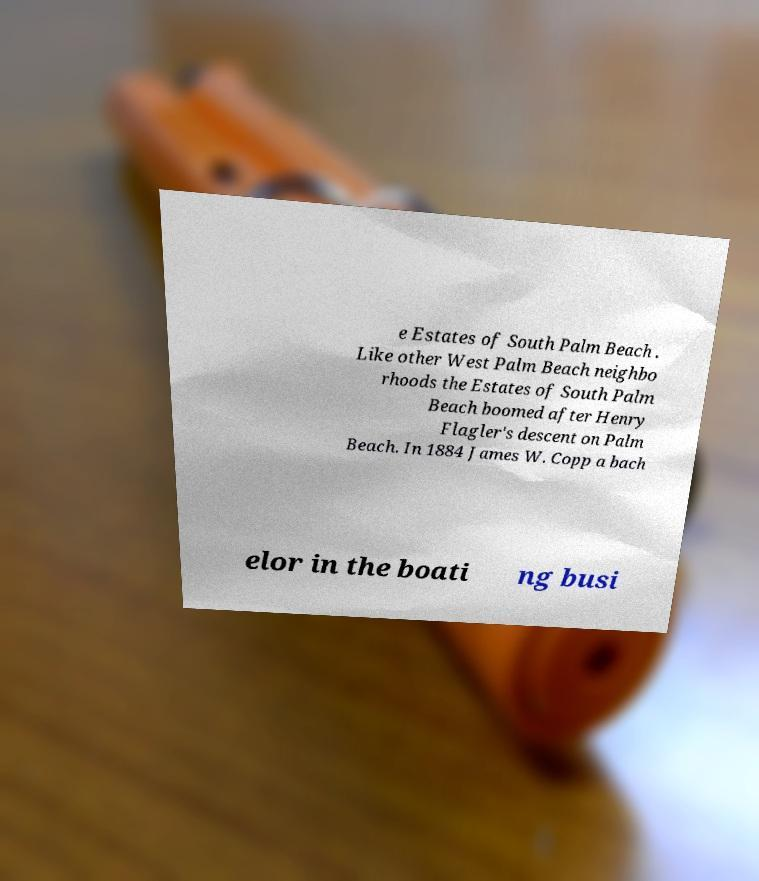Could you assist in decoding the text presented in this image and type it out clearly? e Estates of South Palm Beach . Like other West Palm Beach neighbo rhoods the Estates of South Palm Beach boomed after Henry Flagler's descent on Palm Beach. In 1884 James W. Copp a bach elor in the boati ng busi 